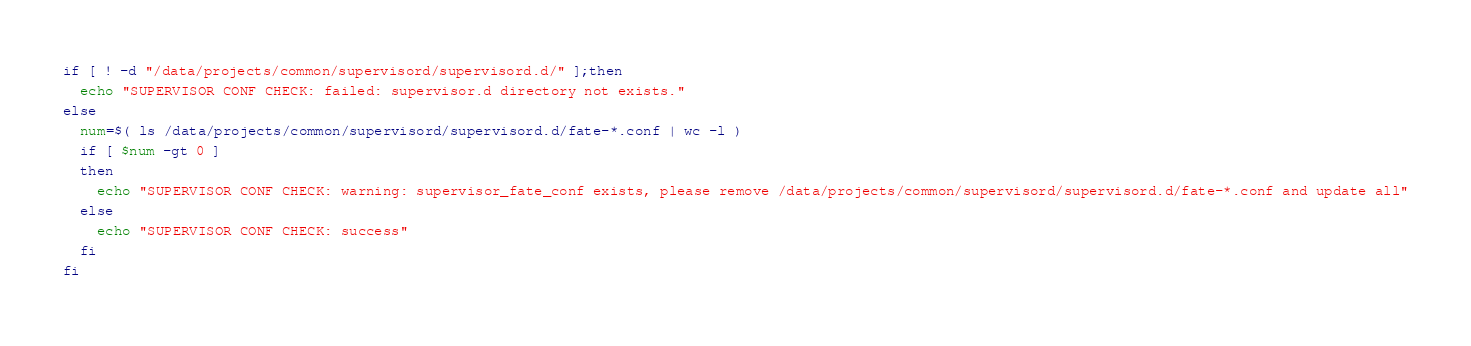Convert code to text. <code><loc_0><loc_0><loc_500><loc_500><_Bash_>if [ ! -d "/data/projects/common/supervisord/supervisord.d/" ];then
  echo "SUPERVISOR CONF CHECK: failed: supervisor.d directory not exists."
else
  num=$( ls /data/projects/common/supervisord/supervisord.d/fate-*.conf | wc -l )
  if [ $num -gt 0 ]
  then
    echo "SUPERVISOR CONF CHECK: warning: supervisor_fate_conf exists, please remove /data/projects/common/supervisord/supervisord.d/fate-*.conf and update all"
  else
    echo "SUPERVISOR CONF CHECK: success"
  fi
fi</code> 